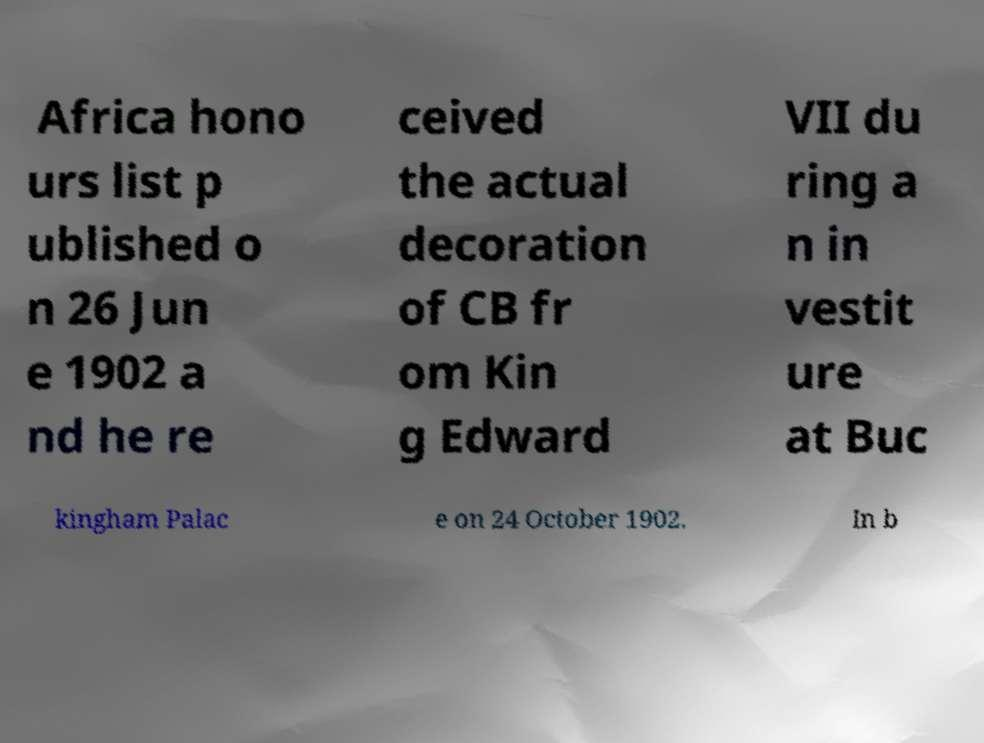For documentation purposes, I need the text within this image transcribed. Could you provide that? Africa hono urs list p ublished o n 26 Jun e 1902 a nd he re ceived the actual decoration of CB fr om Kin g Edward VII du ring a n in vestit ure at Buc kingham Palac e on 24 October 1902. In b 